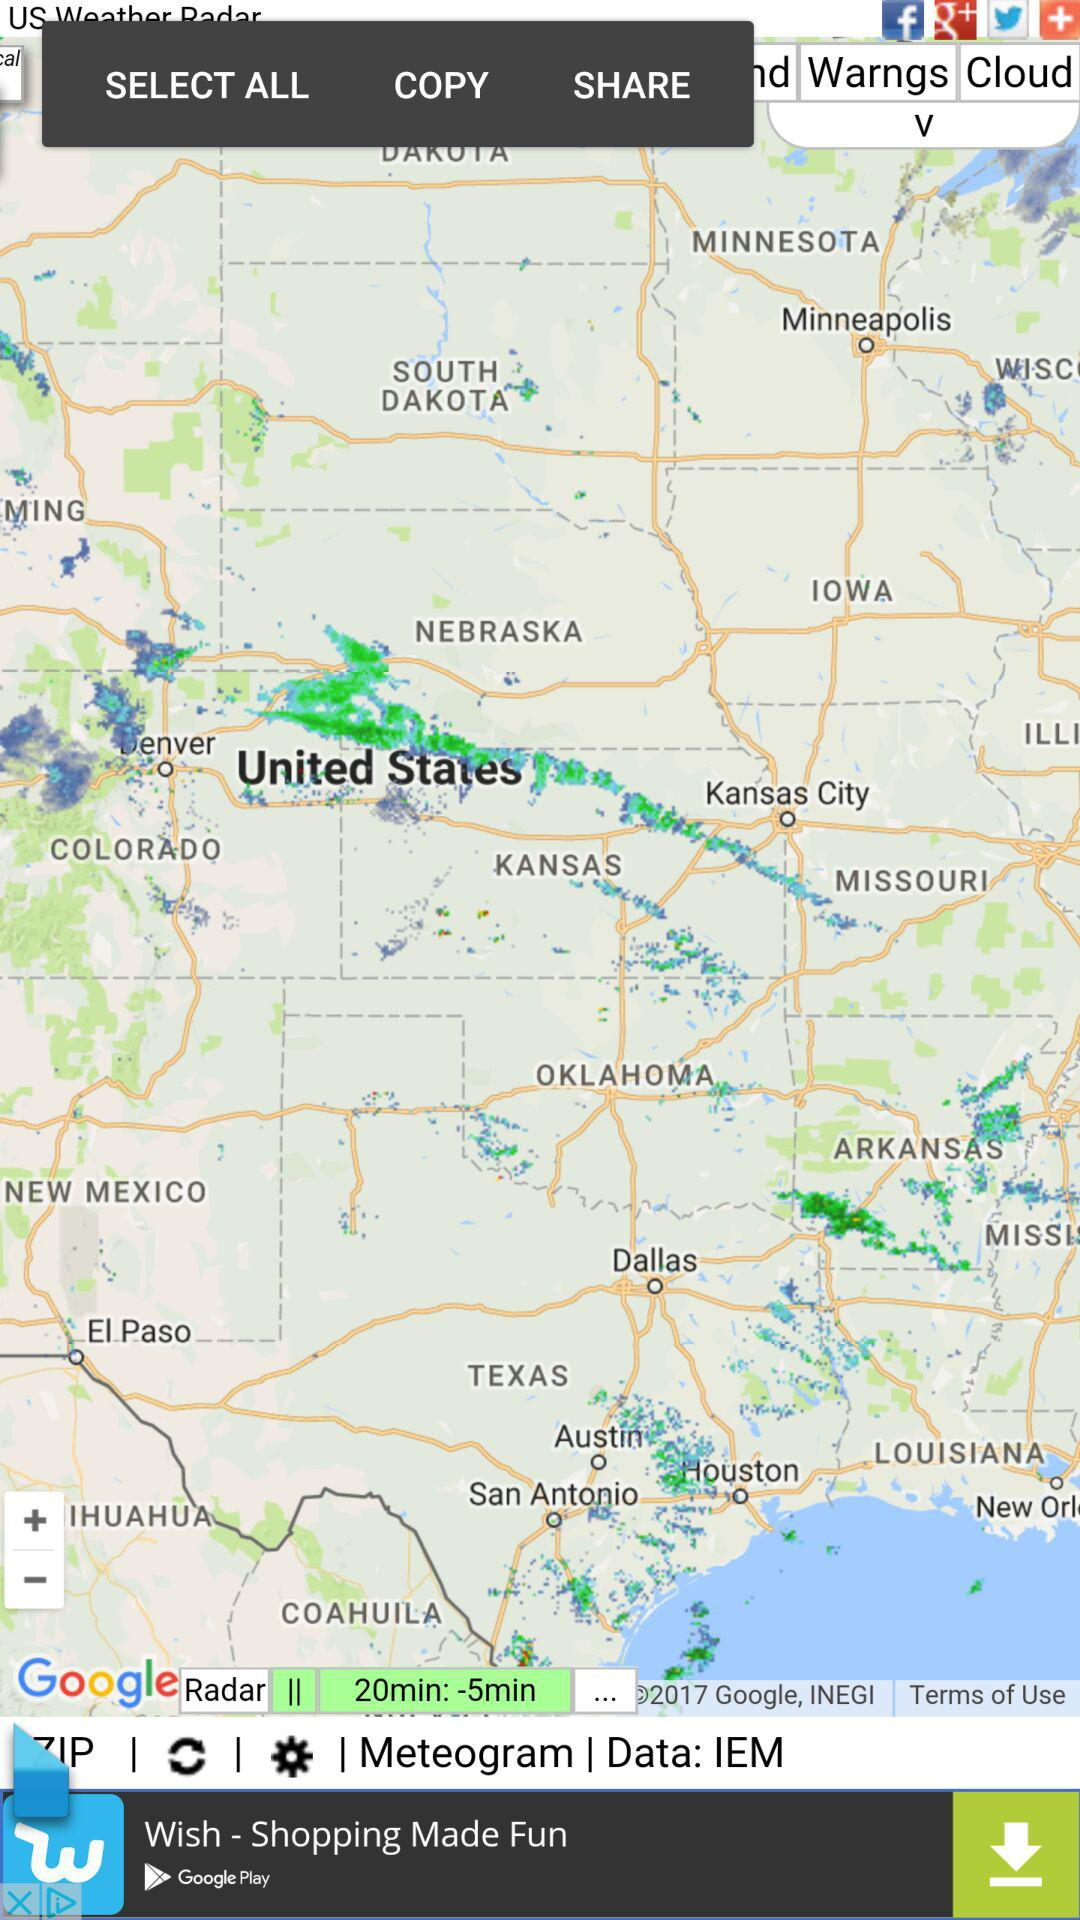What is the radar duration in the map?
When the provided information is insufficient, respond with <no answer>. <no answer> 